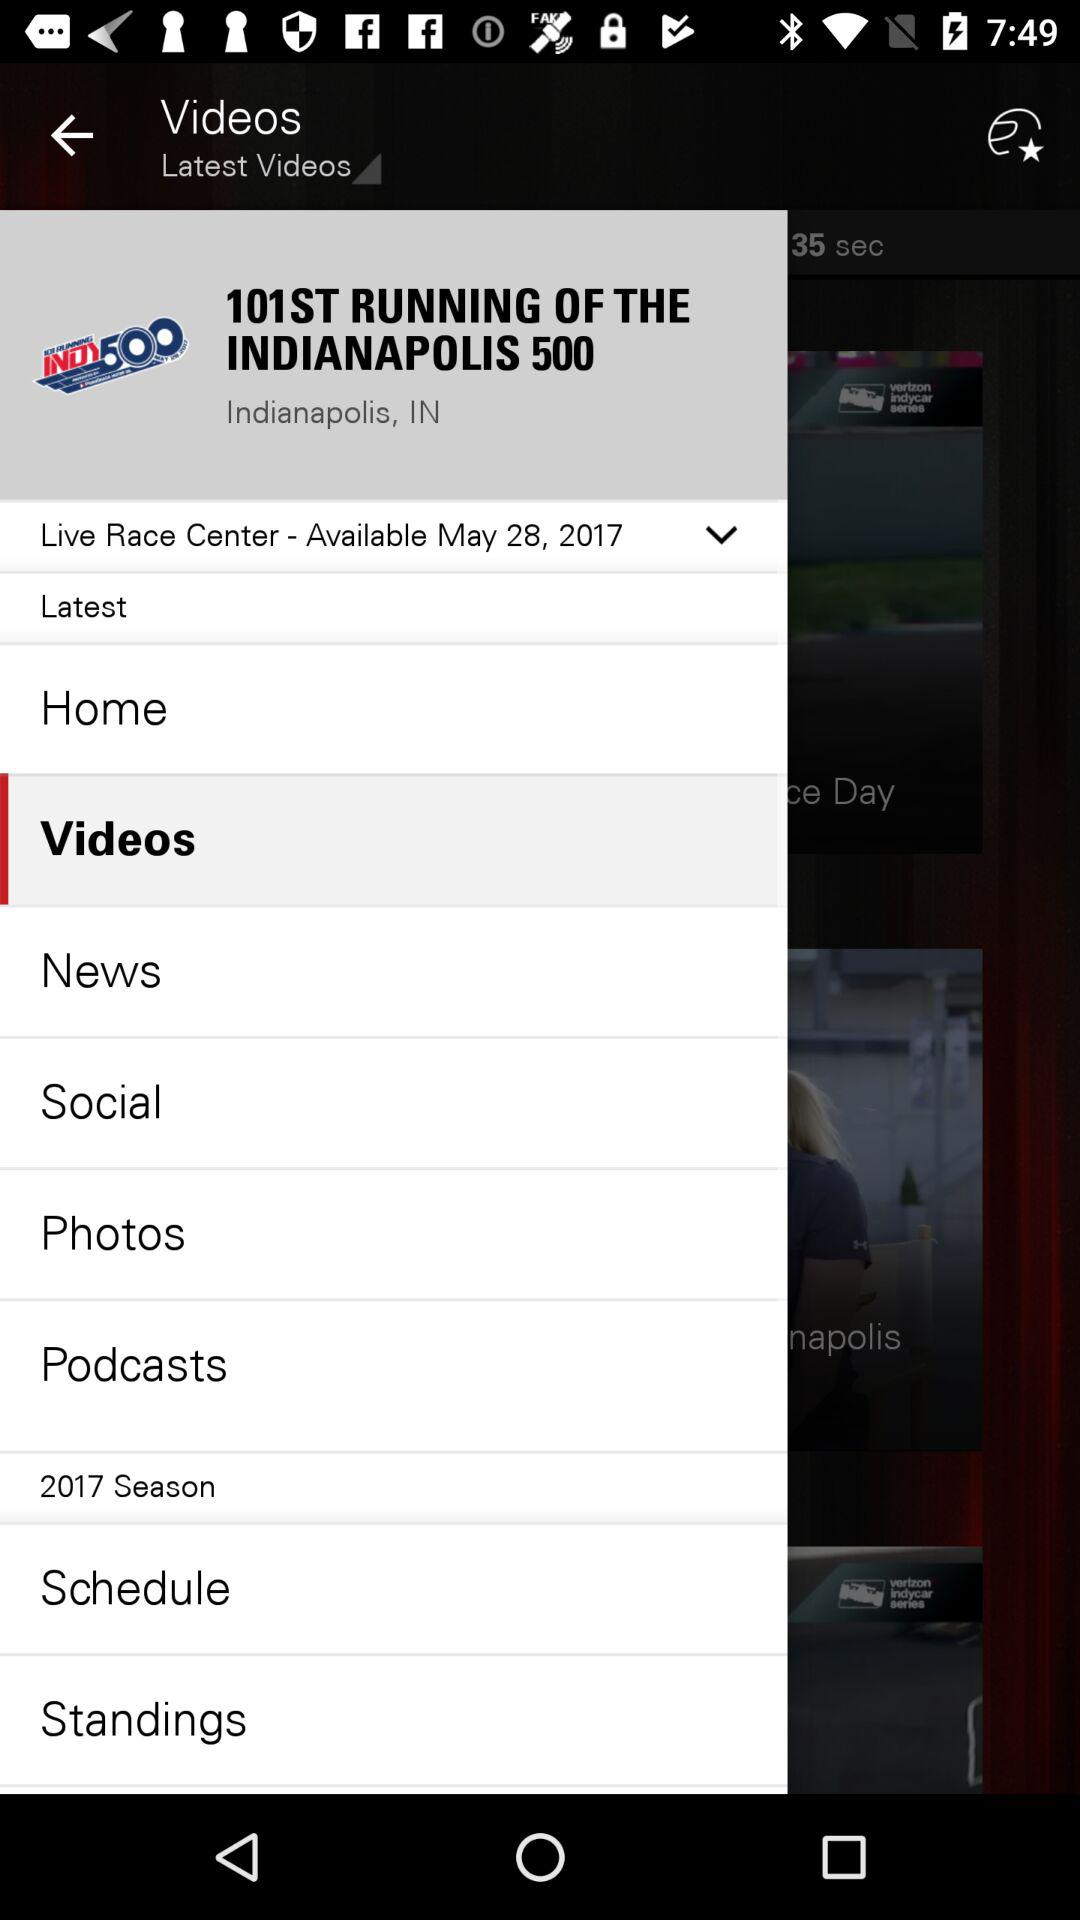Which tab has been selected? The selected tab is "Videos". 